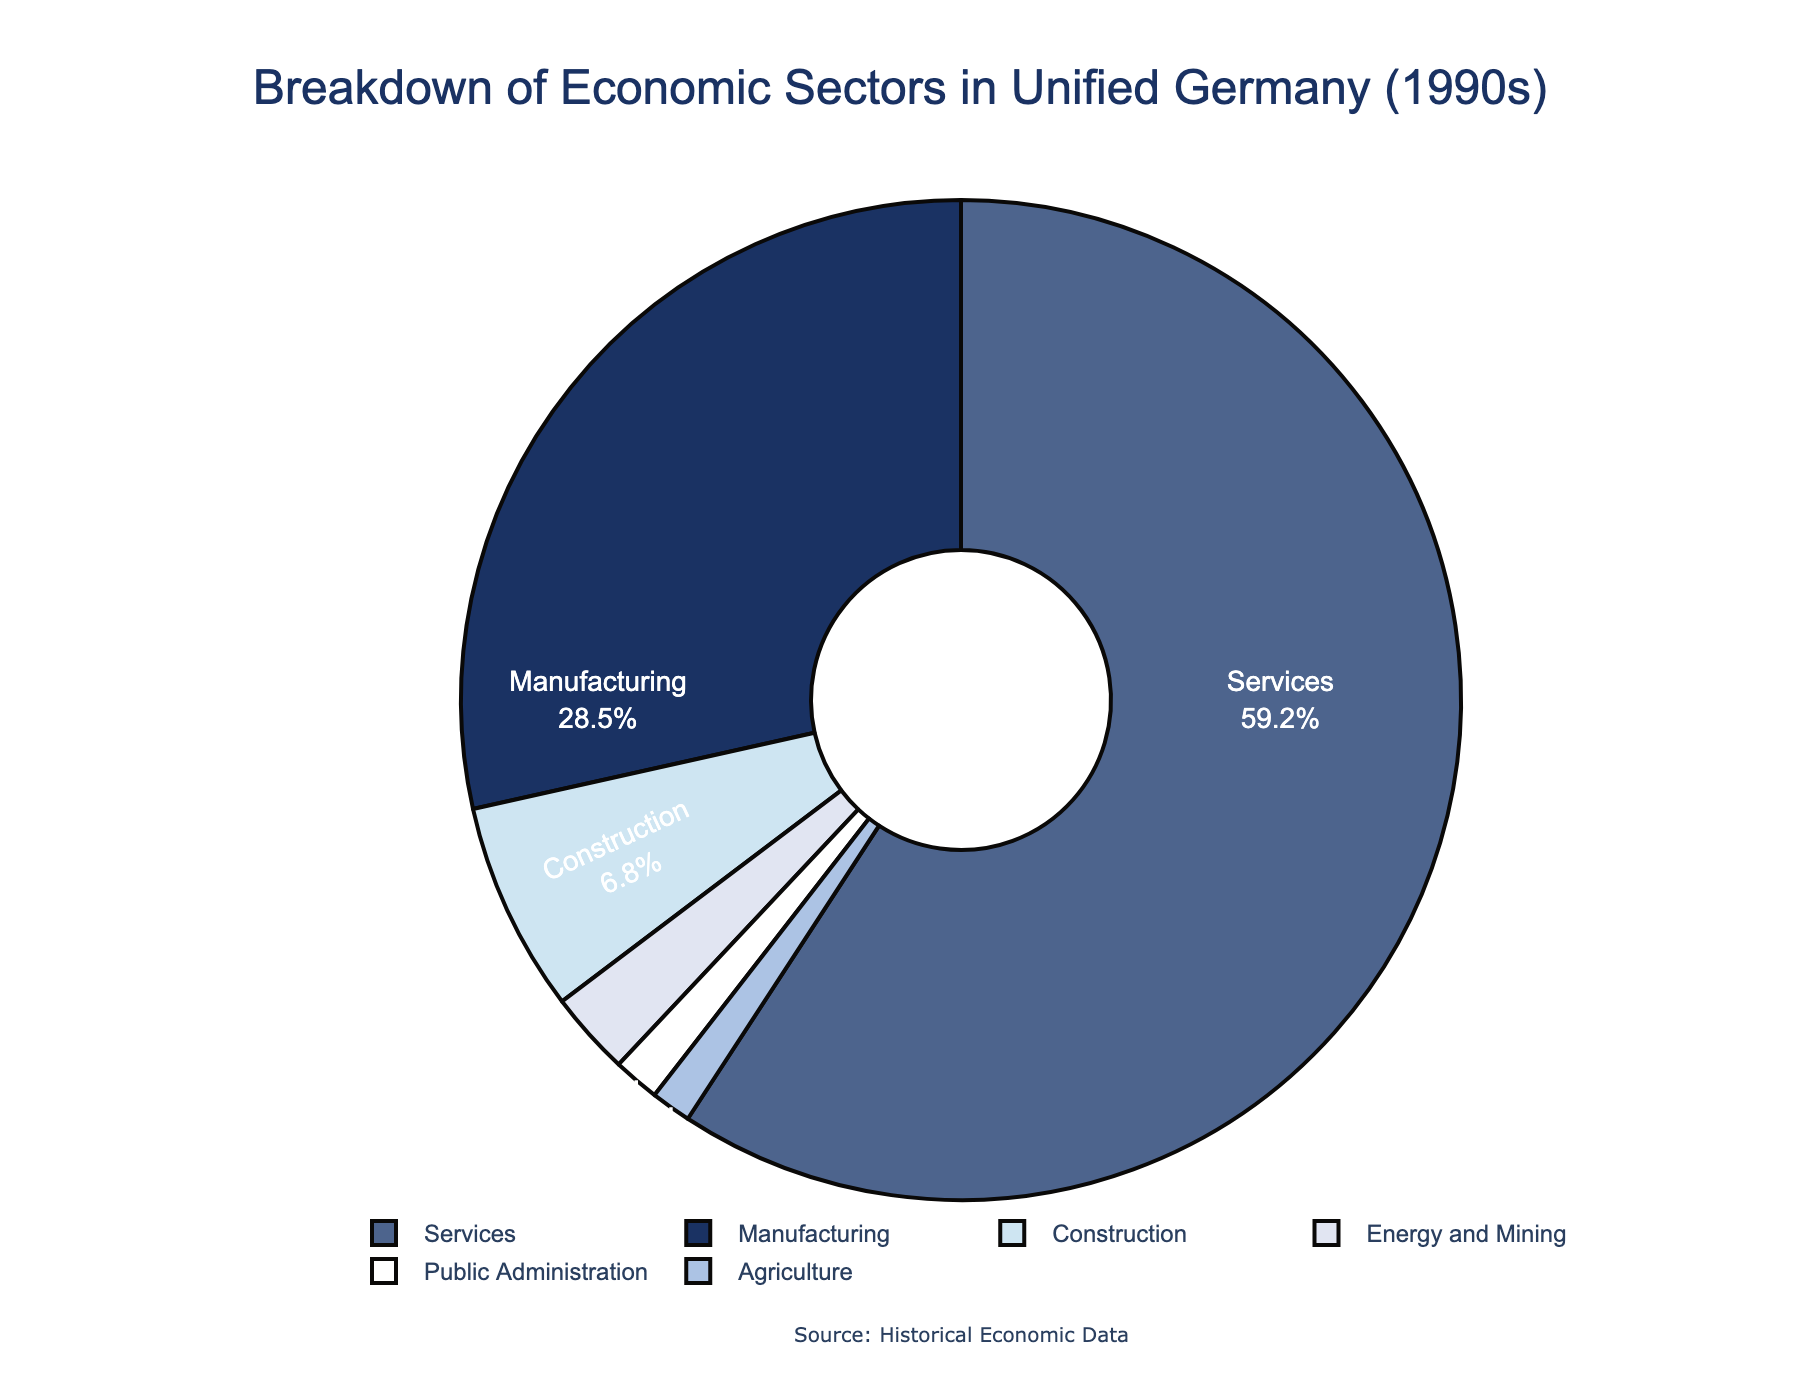what percentage of the economy does agriculture and public administration collectively account for? To find the collective percentage of agriculture and public administration, add their respective percentages: 1.3% (agriculture) + 1.5% (public administration) = 2.8%.
Answer: 2.8% which sector has the largest share of the economy? The sector with the largest share is the one with the highest percentage. In the chart, the services sector has the largest percentage at 59.2%.
Answer: services how much more significant is the manufacturing sector compared to the agriculture sector? Subtract the percentage of agriculture from the percentage of manufacturing to determine the difference: 28.5% (manufacturing) - 1.3% (agriculture) = 27.2%.
Answer: 27.2% which sectors combined make up more than half of the economy? Identify which combination(s) of sectors would total more than 50%. The services sector alone already exceeds 50% with 59.2%.
Answer: services alone does the construction sector make up a larger share than energy and mining? Compare the percentages of the construction sector (6.8%) and the energy and mining sector (2.7%). Since 6.8% is greater than 2.7%, construction has a larger share.
Answer: yes, construction which sectors occupy less than 5% each of the economy? List the sectors with percentages less than 5%: agriculture (1.3%), energy and mining (2.7%), public administration (1.5%).
Answer: agriculture, energy and mining, public administration what percentage of the economy do non-service sectors account for? Sum the percentages of all sectors except services: 28.5% (manufacturing) + 1.3% (agriculture) + 6.8% (construction) + 2.7% (energy and mining) + 1.5% (public administration) = 40.8%.
Answer: 40.8% how does the share of manufacturing compare to the combined share of public administration and energy and mining? Combine the percentages of public administration (1.5%) and energy and mining (2.7%) to get 4.2%, then compare this to the manufacturing percentage (28.5%). Manufacturing is larger.
Answer: manufacturing is larger if you combined the shares of construction and agriculture, would it be larger than the energy and mining sector? Add the percentages of construction (6.8%) and agriculture (1.3%), which equals 8.1%. This is larger than the energy and mining sector (2.7%).
Answer: yes 